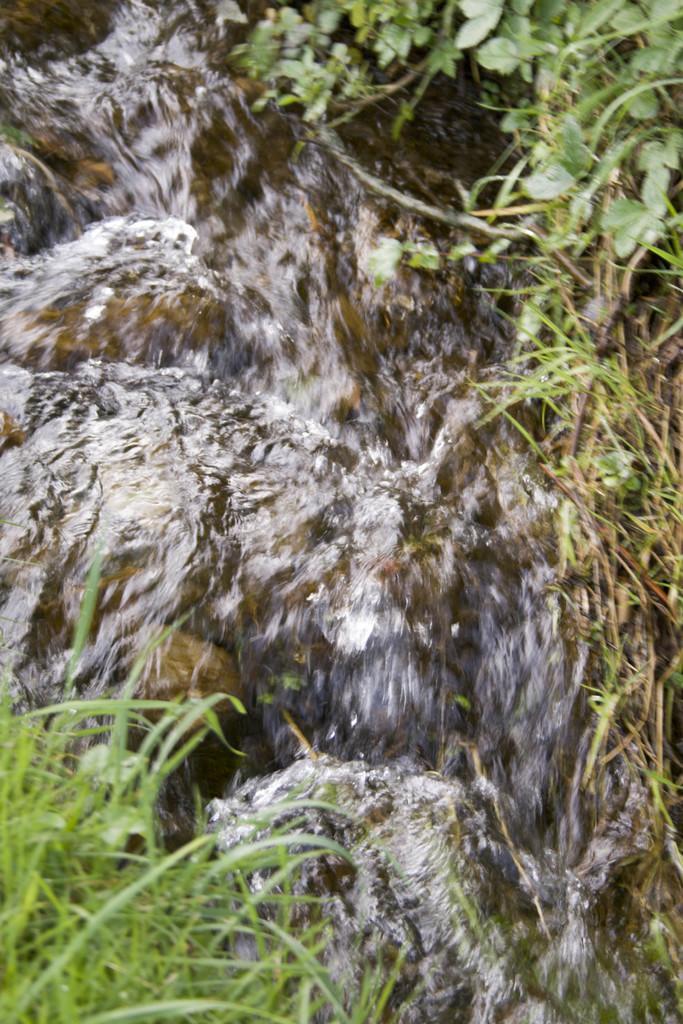In one or two sentences, can you explain what this image depicts? In this image there is the water flowing. In the either sides of the water there's grass on the ground. In the top right there are leaves of a plant. 